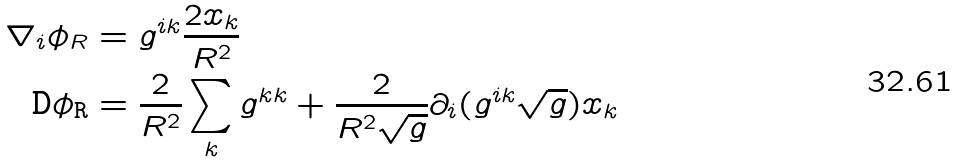<formula> <loc_0><loc_0><loc_500><loc_500>\nabla _ { i } \phi _ { R } & = g ^ { i k } \frac { 2 x _ { k } } { R ^ { 2 } } \\ \tt D \phi _ { R } & = \frac { 2 } { R ^ { 2 } } \sum _ { k } g ^ { k k } + \frac { 2 } { R ^ { 2 } \sqrt { g } } \partial _ { i } ( g ^ { i k } \sqrt { g } ) x _ { k } \\</formula> 